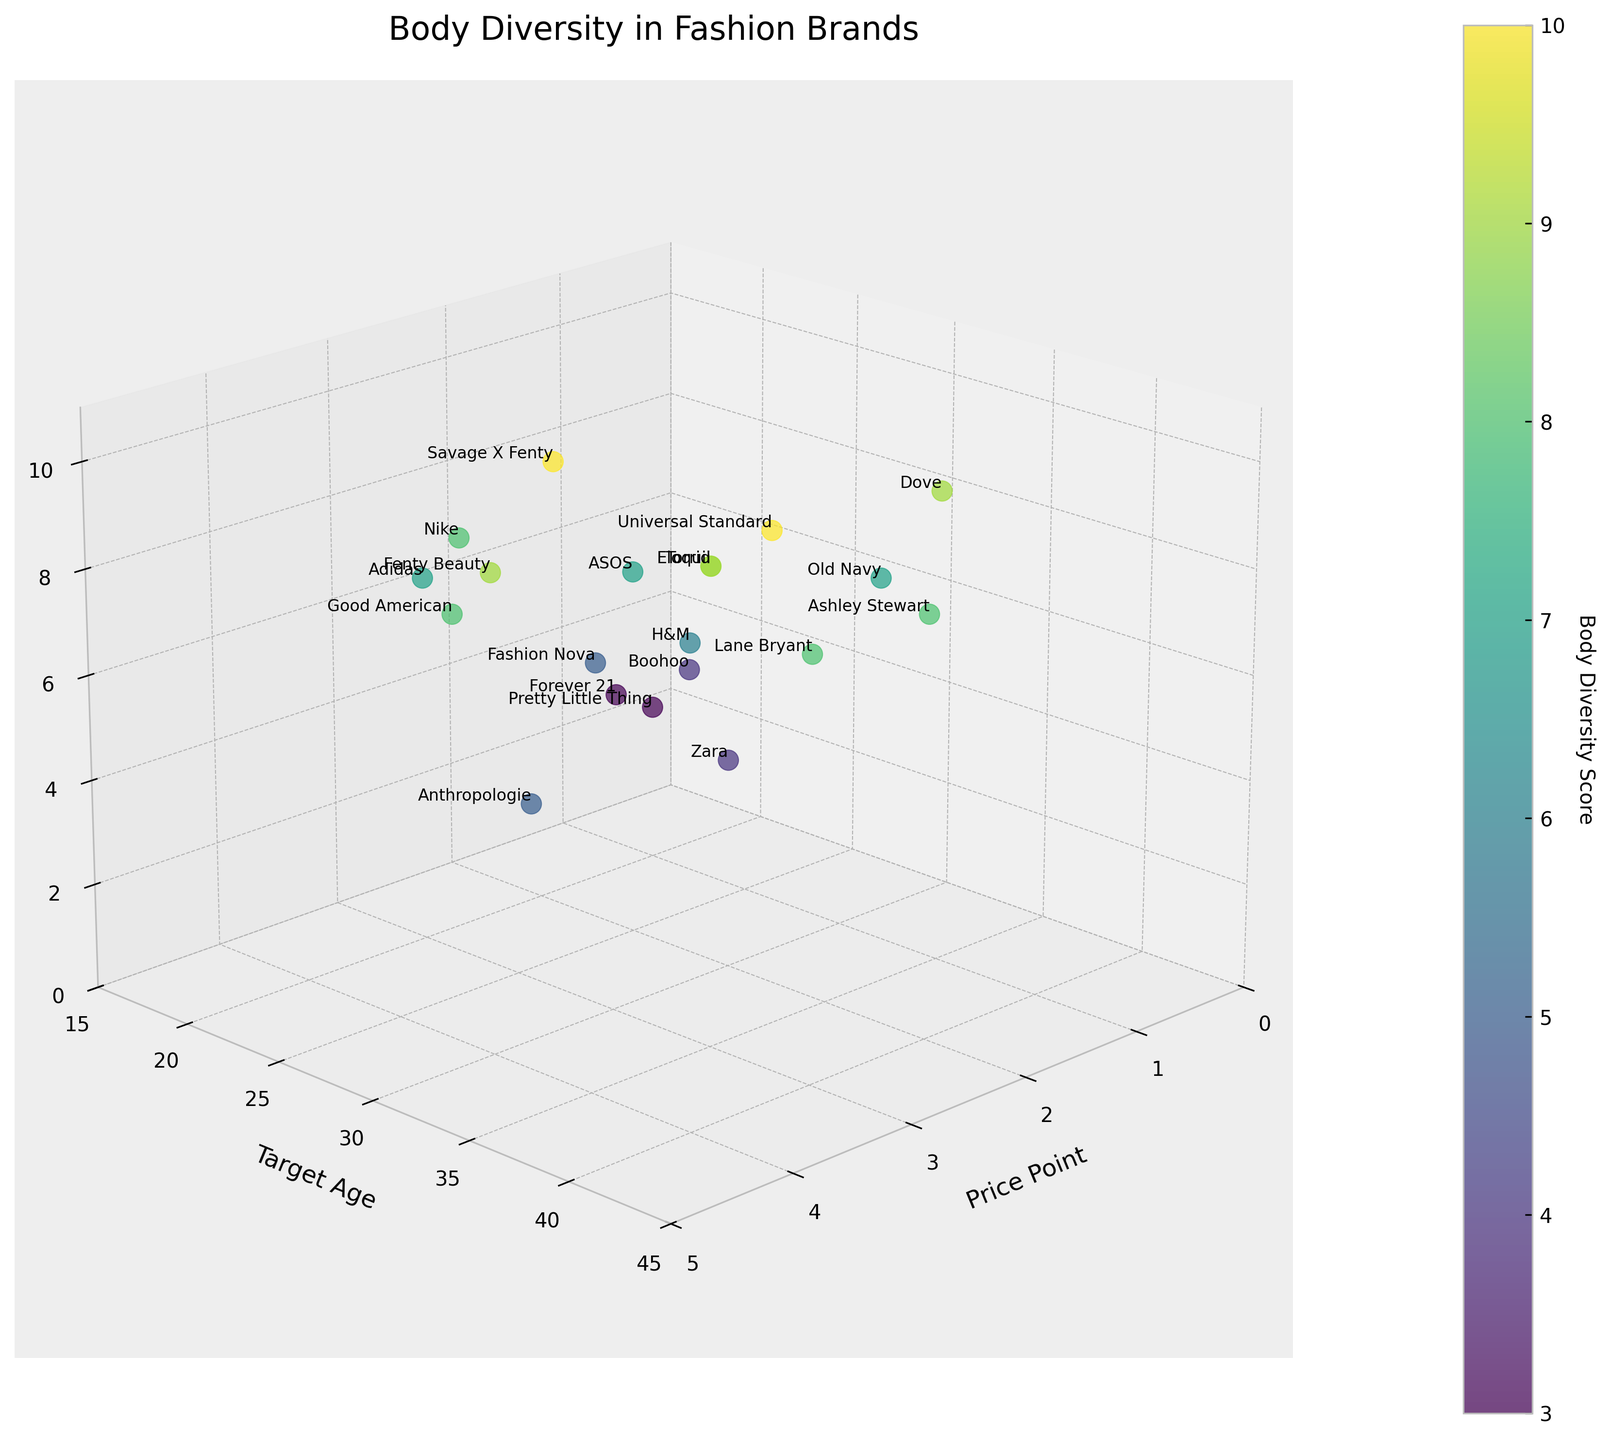What's the title of the figure? The title can be found at the top of the figure; it summarizes what the plot is about.
Answer: "Body Diversity in Fashion Brands" What are the axes labels in the plot? The axes labels are found along each axis indicating what each dimension represents.
Answer: Price Point, Target Age, Body Diversity Score How many brands have a Body Diversity Score of 9 or higher? Count the number of data points where the 'Body Diversity Score' value is 9 or higher.
Answer: 7 brands Which brand targets the oldest age group and what is its Body Diversity Score? Look for the point where 'Target Age' is at its maximum and identify the brand and its corresponding 'Body Diversity Score'.
Answer: Lane Bryant, 8 Which brand has the lowest Body Diversity Score across all price points? Find the brand with the smallest 'Body Diversity Score' value among all data points.
Answer: Forever 21 What's the average Body Diversity Score for brands with a target age of 30 and above? Filter brands with 'Target Age' 30 and above, sum their 'Body Diversity Score', and divide by the count.
Answer: (9 + 7 + 8 + 10 + 9 + 8)/6 = 8.5 Between 'Nike' and 'Adidas', which has a higher Body Diversity Score and by how much? Compare the 'Body Diversity Score' of Nike and Adidas and subtract the smaller from the larger score.
Answer: Nike by 1 What price point is most associated with higher Body Diversity Scores? Check the average 'Body Diversity Score' for each price point and identify the highest one.
Answer: Price Point 3.5 How does the representation of different body types vary with the price point in the figure? Observe any trends or clustering of data points as 'Price Point' increases and describe any noticeable patterns in 'Body Diversity Score'.
Answer: Higher price points tend to have higher Body Diversity Scores Is there a correlation between 'Target Age' and 'Body Diversity Score'? Examine the scatter plot to identify any visible trend or pattern as one moves along the 'Target Age' axis in relation to 'Body Diversity Score'.
Answer: Weak to Moderate Positive Correlation 